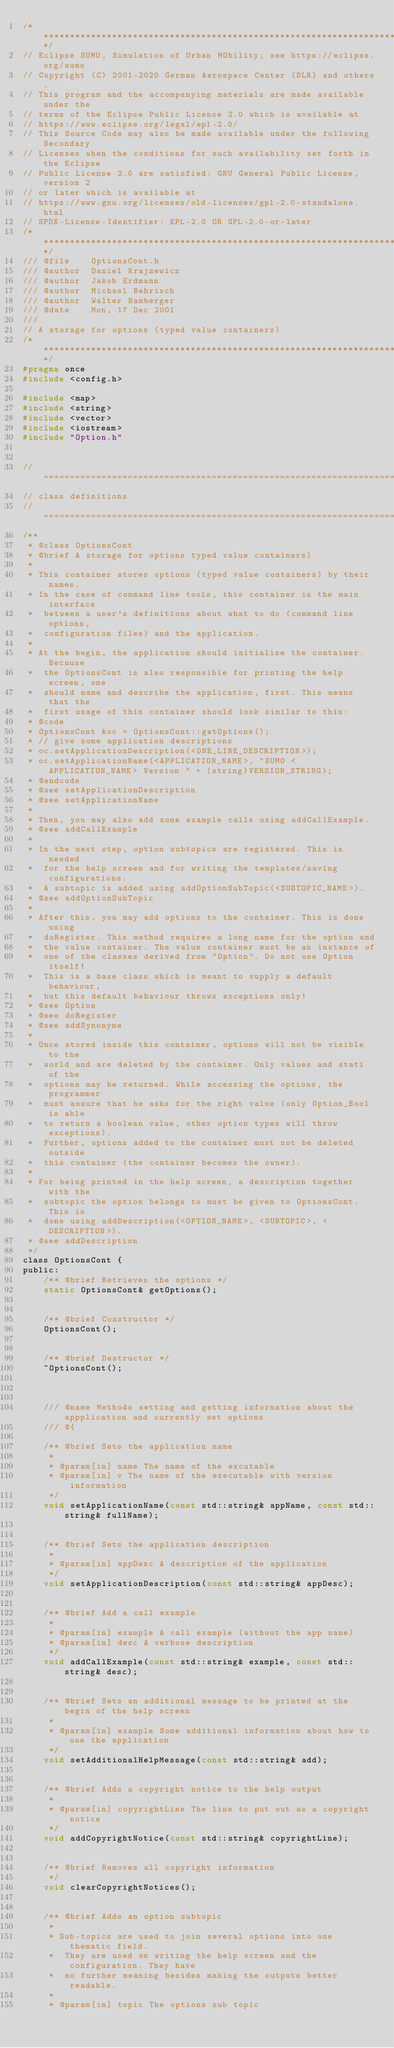<code> <loc_0><loc_0><loc_500><loc_500><_C_>/****************************************************************************/
// Eclipse SUMO, Simulation of Urban MObility; see https://eclipse.org/sumo
// Copyright (C) 2001-2020 German Aerospace Center (DLR) and others.
// This program and the accompanying materials are made available under the
// terms of the Eclipse Public License 2.0 which is available at
// https://www.eclipse.org/legal/epl-2.0/
// This Source Code may also be made available under the following Secondary
// Licenses when the conditions for such availability set forth in the Eclipse
// Public License 2.0 are satisfied: GNU General Public License, version 2
// or later which is available at
// https://www.gnu.org/licenses/old-licenses/gpl-2.0-standalone.html
// SPDX-License-Identifier: EPL-2.0 OR GPL-2.0-or-later
/****************************************************************************/
/// @file    OptionsCont.h
/// @author  Daniel Krajzewicz
/// @author  Jakob Erdmann
/// @author  Michael Behrisch
/// @author  Walter Bamberger
/// @date    Mon, 17 Dec 2001
///
// A storage for options (typed value containers)
/****************************************************************************/
#pragma once
#include <config.h>

#include <map>
#include <string>
#include <vector>
#include <iostream>
#include "Option.h"


// ===========================================================================
// class definitions
// ===========================================================================
/**
 * @class OptionsCont
 * @brief A storage for options typed value containers)
 *
 * This container stores options (typed value containers) by their names.
 * In the case of command line tools, this container is the main interface
 *  between a user's definitions about what to do (command line options,
 *  configuration files) and the application.
 *
 * At the begin, the application should initialise the container. Because
 *  the OptionsCont is also responsible for printing the help screen, one
 *  should name and describe the application, first. This means that the
 *  first usage of this container should look similar to this:
 * @code
 * OptionsCont &oc = OptionsCont::getOptions();
 * // give some application descriptions
 * oc.setApplicationDescription(<ONE_LINE_DESCRIPTION>);
 * oc.setApplicationName(<APPLICATION_NAME>, "SUMO <APPLICATION_NAME> Version " + (string)VERSION_STRING);
 * @endcode
 * @see setApplicationDescription
 * @see setApplicationName
 *
 * Then, you may also add some example calls using addCallExample.
 * @see addCallExample
 *
 * In the next step, option subtopics are registered. This is needed
 *  for the help screen and for writing the templates/saving configurations.
 *  A subtopic is added using addOptionSubTopic(<SUBTOPIC_NAME>).
 * @see addOptionSubTopic
 *
 * After this, you may add options to the container. This is done using
 *  doRegister. This method requires a long name for the option and
 *  the value container. The value container must be an instance of
 *  one of the classes derived from "Option". Do not use Option itself!
 *  This is a base class which is meant to supply a default behaviour,
 *  but this default behaviour throws exceptions only!
 * @see Option
 * @see doRegister
 * @see addSynonyme
 *
 * Once stored inside this container, options will not be visible to the
 *  world and are deleted by the container. Only values and stati of the
 *  options may be returned. While accessing the options, the programmer
 *  must assure that he asks for the right value (only Option_Bool is able
 *  to return a boolean value, other option types will throw exceptions).
 *  Further, options added to the container must not be deleted outside
 *  this container (the container becomes the owner).
 *
 * For being printed in the help screen, a description together with the
 *  subtopic the option belongs to must be given to OptionsCont. This is
 *  done using addDescription(<OPTION_NAME>, <SUBTOPIC>, <DESCRIPTION>).
 * @see addDescription
 */
class OptionsCont {
public:
    /** @brief Retrieves the options */
    static OptionsCont& getOptions();


    /** @brief Constructor */
    OptionsCont();


    /** @brief Destructor */
    ~OptionsCont();



    /// @name Methods setting and getting information about the appplication and currently set options
    /// @{

    /** @brief Sets the application name
     *
     * @param[in] name The name of the excutable
     * @param[in] v The name of the executable with version information
     */
    void setApplicationName(const std::string& appName, const std::string& fullName);


    /** @brief Sets the application description
     *
     * @param[in] appDesc A description of the application
     */
    void setApplicationDescription(const std::string& appDesc);


    /** @brief Add a call example
     *
     * @param[in] example A call example (without the app name)
     * @param[in] desc A verbose description
     */
    void addCallExample(const std::string& example, const std::string& desc);


    /** @brief Sets an additional message to be printed at the begin of the help screen
     *
     * @param[in] example Some additional information about how to use the application
     */
    void setAdditionalHelpMessage(const std::string& add);


    /** @brief Adds a copyright notice to the help output
     *
     * @param[in] copyrightLine The line to put out as a copyright notice
     */
    void addCopyrightNotice(const std::string& copyrightLine);


    /** @brief Removes all copyright information
     */
    void clearCopyrightNotices();


    /** @brief Adds an option subtopic
     *
     * Sub-topics are used to join several options into one thematic field.
     *  They are used on writing the help screen and the configuration. They have
     *  no further meaning besides making the outputs better readable.
     *
     * @param[in] topic The options sub topic</code> 